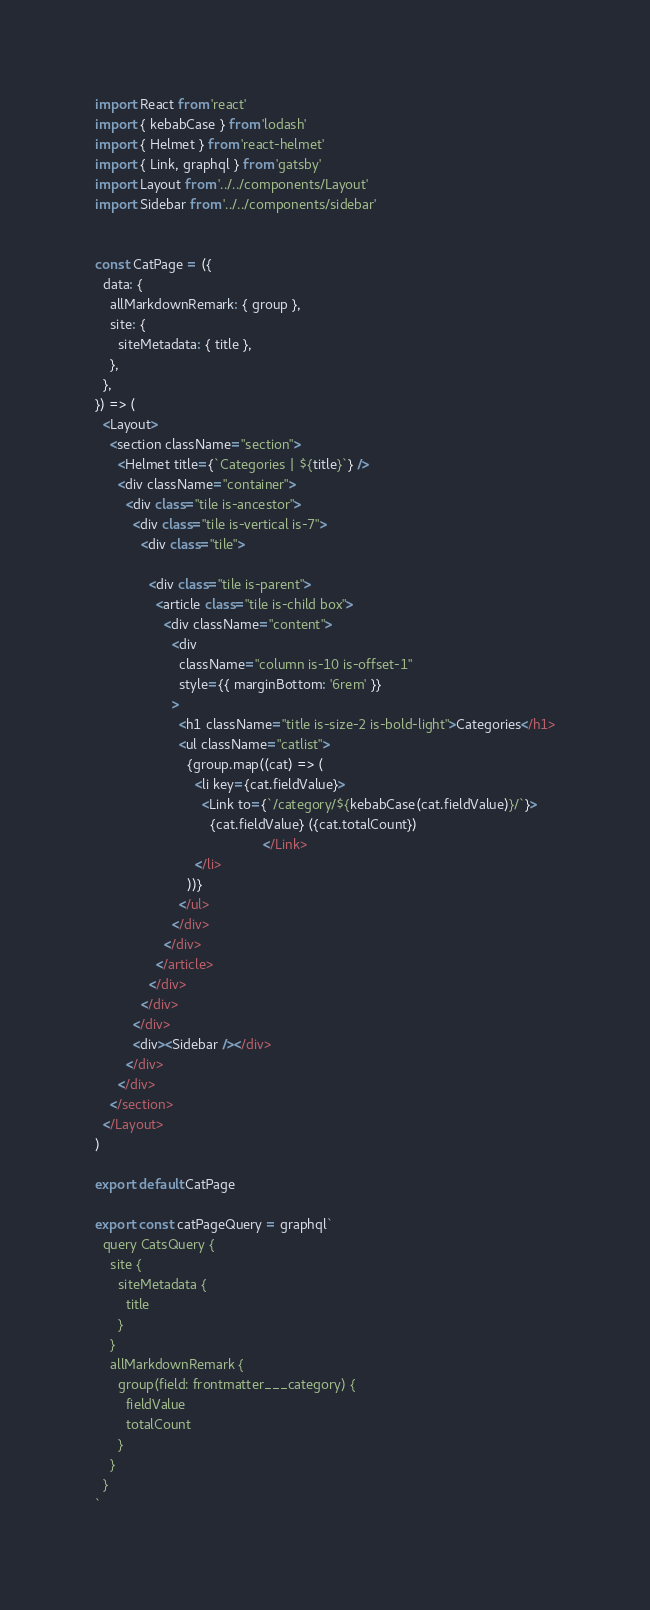Convert code to text. <code><loc_0><loc_0><loc_500><loc_500><_JavaScript_>import React from 'react'
import { kebabCase } from 'lodash'
import { Helmet } from 'react-helmet'
import { Link, graphql } from 'gatsby'
import Layout from '../../components/Layout'
import Sidebar from '../../components/sidebar'


const CatPage = ({
  data: {
    allMarkdownRemark: { group },
    site: {
      siteMetadata: { title },
    },
  },
}) => (
  <Layout>
    <section className="section">
      <Helmet title={`Categories | ${title}`} />
      <div className="container">
        <div class="tile is-ancestor">
          <div class="tile is-vertical is-7">
            <div class="tile">

              <div class="tile is-parent">
                <article class="tile is-child box">
                  <div className="content">
                    <div
                      className="column is-10 is-offset-1"
                      style={{ marginBottom: '6rem' }}
                    >
                      <h1 className="title is-size-2 is-bold-light">Categories</h1>
                      <ul className="catlist">
                        {group.map((cat) => (
                          <li key={cat.fieldValue}>
                            <Link to={`/category/${kebabCase(cat.fieldValue)}/`}>
                              {cat.fieldValue} ({cat.totalCount})
                                            </Link>
                          </li>
                        ))}
                      </ul>
                    </div>
                  </div>
                </article>
              </div>
            </div>
          </div>
          <div><Sidebar /></div>
        </div>
      </div>
    </section>
  </Layout>
)

export default CatPage

export const catPageQuery = graphql`
  query CatsQuery {
    site {
      siteMetadata {
        title
      }
    }
    allMarkdownRemark {
      group(field: frontmatter___category) {
        fieldValue
        totalCount
      }
    }
  }
`
</code> 